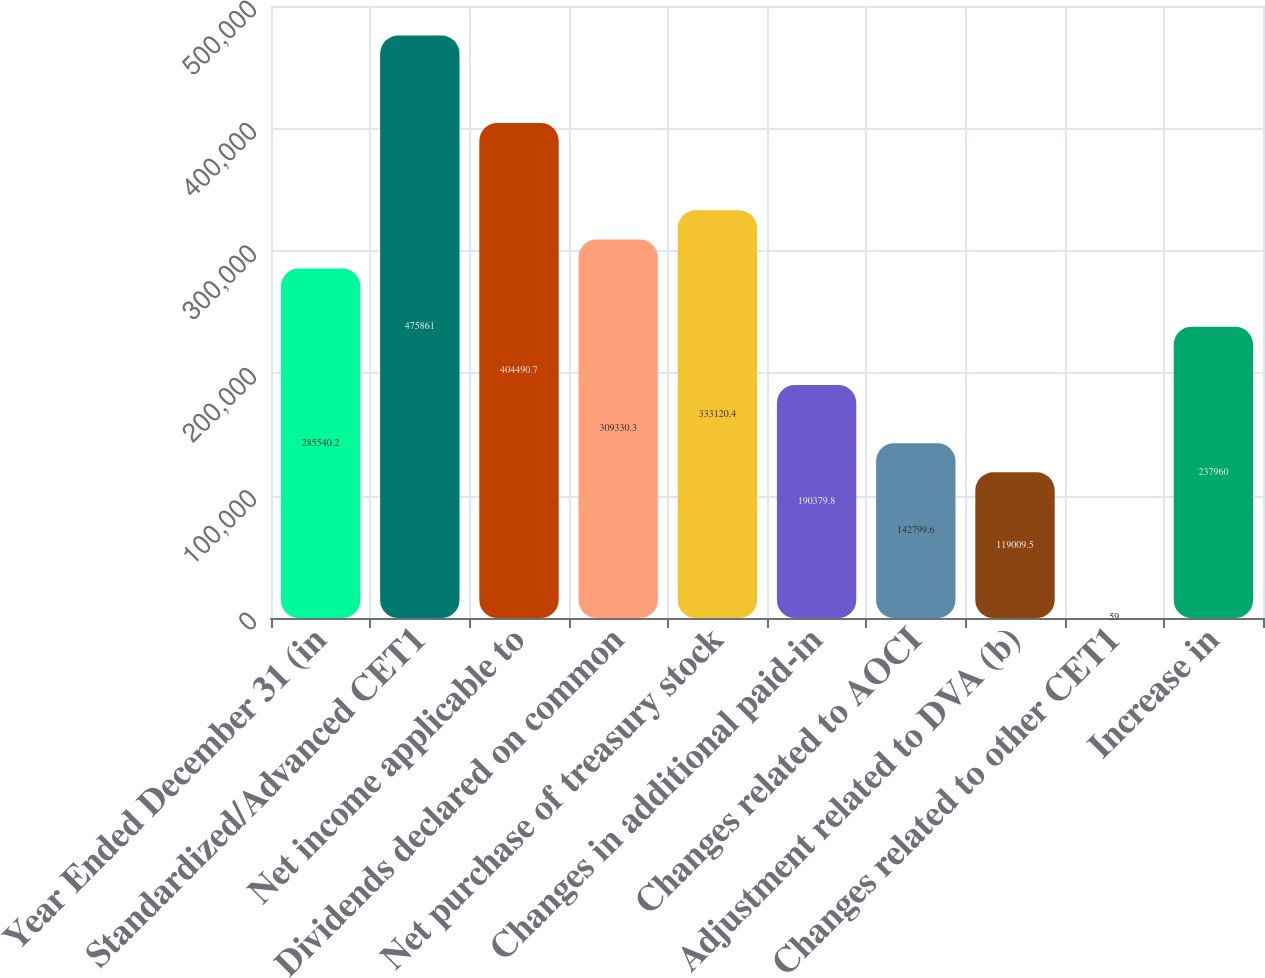Convert chart. <chart><loc_0><loc_0><loc_500><loc_500><bar_chart><fcel>Year Ended December 31 (in<fcel>Standardized/Advanced CET1<fcel>Net income applicable to<fcel>Dividends declared on common<fcel>Net purchase of treasury stock<fcel>Changes in additional paid-in<fcel>Changes related to AOCI<fcel>Adjustment related to DVA (b)<fcel>Changes related to other CET1<fcel>Increase in<nl><fcel>285540<fcel>475861<fcel>404491<fcel>309330<fcel>333120<fcel>190380<fcel>142800<fcel>119010<fcel>59<fcel>237960<nl></chart> 